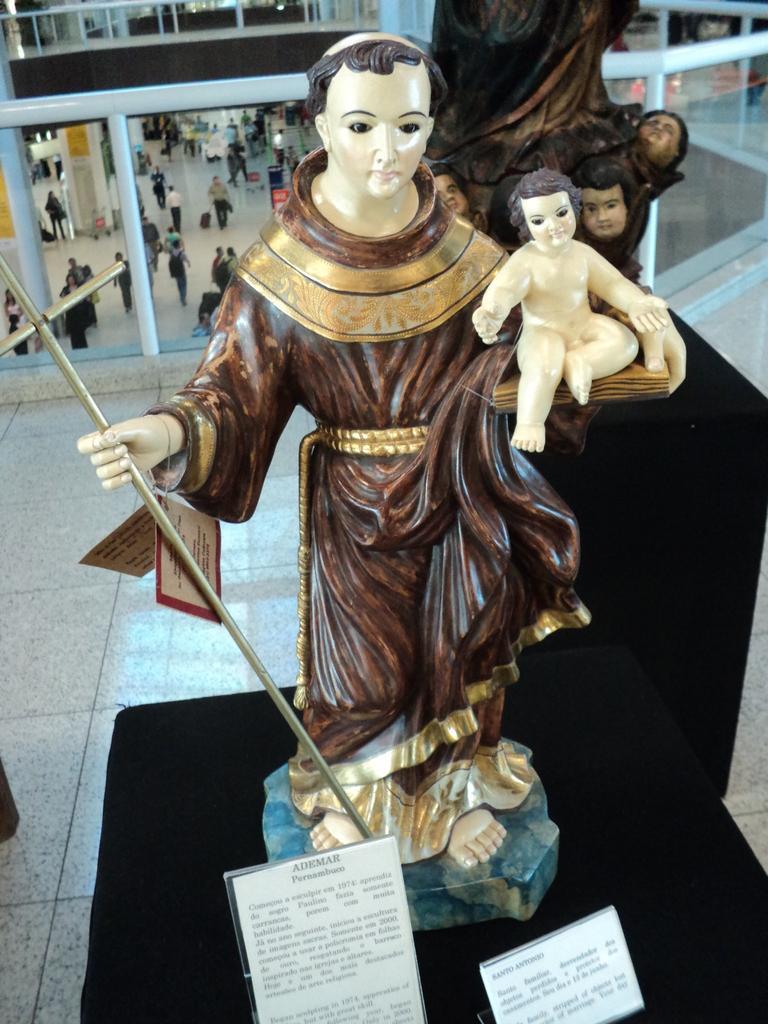How would you summarize this image in a sentence or two? In this image we can see sculptures with name boards on the black color surface. In the background, we can see glass railing. Behind the railing, people are walking on the floor. 